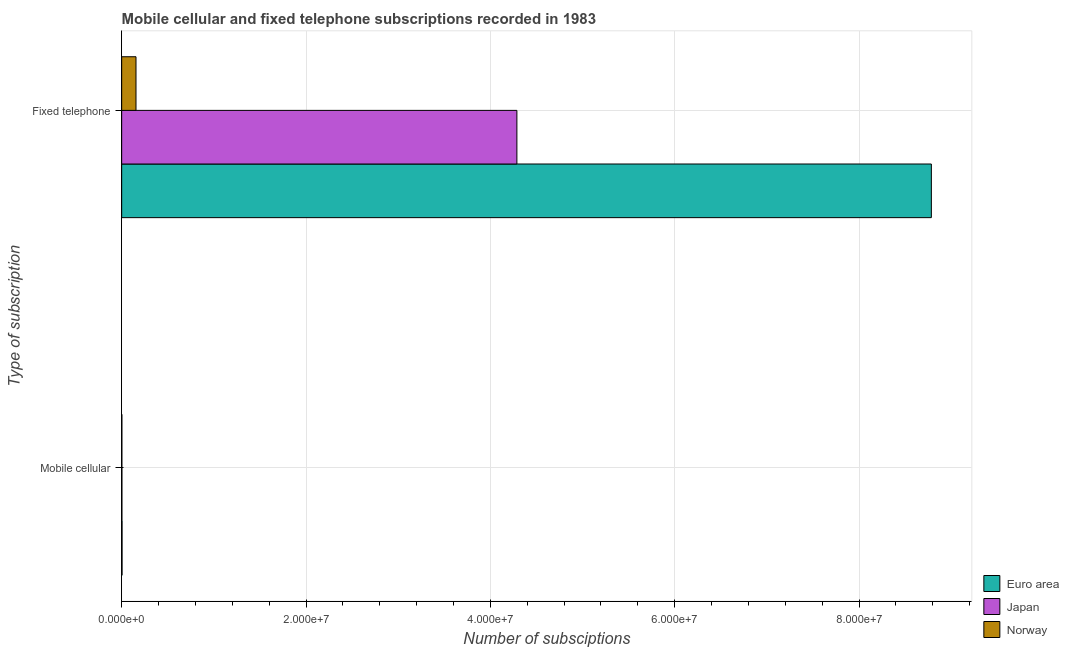How many different coloured bars are there?
Provide a succinct answer. 3. Are the number of bars on each tick of the Y-axis equal?
Provide a short and direct response. Yes. How many bars are there on the 1st tick from the bottom?
Ensure brevity in your answer.  3. What is the label of the 2nd group of bars from the top?
Provide a short and direct response. Mobile cellular. What is the number of fixed telephone subscriptions in Japan?
Your answer should be compact. 4.29e+07. Across all countries, what is the maximum number of fixed telephone subscriptions?
Give a very brief answer. 8.78e+07. Across all countries, what is the minimum number of mobile cellular subscriptions?
Your answer should be compact. 2.35e+04. What is the total number of fixed telephone subscriptions in the graph?
Give a very brief answer. 1.32e+08. What is the difference between the number of fixed telephone subscriptions in Norway and that in Euro area?
Give a very brief answer. -8.63e+07. What is the difference between the number of fixed telephone subscriptions in Japan and the number of mobile cellular subscriptions in Euro area?
Provide a succinct answer. 4.28e+07. What is the average number of mobile cellular subscriptions per country?
Provide a short and direct response. 3.10e+04. What is the difference between the number of fixed telephone subscriptions and number of mobile cellular subscriptions in Japan?
Offer a terse response. 4.29e+07. In how many countries, is the number of mobile cellular subscriptions greater than 4000000 ?
Ensure brevity in your answer.  0. What is the ratio of the number of mobile cellular subscriptions in Japan to that in Norway?
Provide a succinct answer. 1.16. In how many countries, is the number of fixed telephone subscriptions greater than the average number of fixed telephone subscriptions taken over all countries?
Your answer should be compact. 1. What does the 2nd bar from the top in Mobile cellular represents?
Your answer should be compact. Japan. How many bars are there?
Give a very brief answer. 6. What is the difference between two consecutive major ticks on the X-axis?
Your response must be concise. 2.00e+07. Are the values on the major ticks of X-axis written in scientific E-notation?
Your answer should be very brief. Yes. Does the graph contain any zero values?
Provide a succinct answer. No. Does the graph contain grids?
Provide a short and direct response. Yes. How many legend labels are there?
Keep it short and to the point. 3. How are the legend labels stacked?
Give a very brief answer. Vertical. What is the title of the graph?
Ensure brevity in your answer.  Mobile cellular and fixed telephone subscriptions recorded in 1983. What is the label or title of the X-axis?
Offer a terse response. Number of subsciptions. What is the label or title of the Y-axis?
Your answer should be compact. Type of subscription. What is the Number of subsciptions in Euro area in Mobile cellular?
Offer a terse response. 4.22e+04. What is the Number of subsciptions in Japan in Mobile cellular?
Offer a terse response. 2.72e+04. What is the Number of subsciptions of Norway in Mobile cellular?
Offer a terse response. 2.35e+04. What is the Number of subsciptions of Euro area in Fixed telephone?
Offer a terse response. 8.78e+07. What is the Number of subsciptions in Japan in Fixed telephone?
Keep it short and to the point. 4.29e+07. What is the Number of subsciptions of Norway in Fixed telephone?
Offer a terse response. 1.55e+06. Across all Type of subscription, what is the maximum Number of subsciptions in Euro area?
Your response must be concise. 8.78e+07. Across all Type of subscription, what is the maximum Number of subsciptions of Japan?
Ensure brevity in your answer.  4.29e+07. Across all Type of subscription, what is the maximum Number of subsciptions of Norway?
Your answer should be very brief. 1.55e+06. Across all Type of subscription, what is the minimum Number of subsciptions in Euro area?
Your answer should be compact. 4.22e+04. Across all Type of subscription, what is the minimum Number of subsciptions in Japan?
Provide a succinct answer. 2.72e+04. Across all Type of subscription, what is the minimum Number of subsciptions in Norway?
Make the answer very short. 2.35e+04. What is the total Number of subsciptions of Euro area in the graph?
Keep it short and to the point. 8.79e+07. What is the total Number of subsciptions of Japan in the graph?
Keep it short and to the point. 4.29e+07. What is the total Number of subsciptions in Norway in the graph?
Offer a terse response. 1.58e+06. What is the difference between the Number of subsciptions of Euro area in Mobile cellular and that in Fixed telephone?
Ensure brevity in your answer.  -8.78e+07. What is the difference between the Number of subsciptions of Japan in Mobile cellular and that in Fixed telephone?
Offer a very short reply. -4.29e+07. What is the difference between the Number of subsciptions of Norway in Mobile cellular and that in Fixed telephone?
Offer a very short reply. -1.53e+06. What is the difference between the Number of subsciptions of Euro area in Mobile cellular and the Number of subsciptions of Japan in Fixed telephone?
Give a very brief answer. -4.28e+07. What is the difference between the Number of subsciptions of Euro area in Mobile cellular and the Number of subsciptions of Norway in Fixed telephone?
Ensure brevity in your answer.  -1.51e+06. What is the difference between the Number of subsciptions of Japan in Mobile cellular and the Number of subsciptions of Norway in Fixed telephone?
Keep it short and to the point. -1.53e+06. What is the average Number of subsciptions of Euro area per Type of subscription?
Keep it short and to the point. 4.39e+07. What is the average Number of subsciptions of Japan per Type of subscription?
Offer a terse response. 2.15e+07. What is the average Number of subsciptions of Norway per Type of subscription?
Your answer should be compact. 7.89e+05. What is the difference between the Number of subsciptions of Euro area and Number of subsciptions of Japan in Mobile cellular?
Offer a terse response. 1.50e+04. What is the difference between the Number of subsciptions of Euro area and Number of subsciptions of Norway in Mobile cellular?
Make the answer very short. 1.88e+04. What is the difference between the Number of subsciptions of Japan and Number of subsciptions of Norway in Mobile cellular?
Your answer should be compact. 3725. What is the difference between the Number of subsciptions of Euro area and Number of subsciptions of Japan in Fixed telephone?
Your answer should be very brief. 4.50e+07. What is the difference between the Number of subsciptions of Euro area and Number of subsciptions of Norway in Fixed telephone?
Your response must be concise. 8.63e+07. What is the difference between the Number of subsciptions in Japan and Number of subsciptions in Norway in Fixed telephone?
Your response must be concise. 4.13e+07. What is the ratio of the Number of subsciptions in Japan in Mobile cellular to that in Fixed telephone?
Your response must be concise. 0. What is the ratio of the Number of subsciptions of Norway in Mobile cellular to that in Fixed telephone?
Offer a very short reply. 0.02. What is the difference between the highest and the second highest Number of subsciptions of Euro area?
Your answer should be very brief. 8.78e+07. What is the difference between the highest and the second highest Number of subsciptions in Japan?
Your answer should be very brief. 4.29e+07. What is the difference between the highest and the second highest Number of subsciptions in Norway?
Provide a short and direct response. 1.53e+06. What is the difference between the highest and the lowest Number of subsciptions of Euro area?
Offer a very short reply. 8.78e+07. What is the difference between the highest and the lowest Number of subsciptions in Japan?
Your answer should be very brief. 4.29e+07. What is the difference between the highest and the lowest Number of subsciptions in Norway?
Make the answer very short. 1.53e+06. 